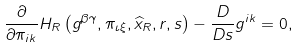Convert formula to latex. <formula><loc_0><loc_0><loc_500><loc_500>\frac { \partial } { \partial \pi _ { i k } } H _ { R } \left ( g ^ { \beta \gamma } , \pi _ { \iota \xi } , \widehat { x } _ { R } , r , s \right ) - \frac { D } { D s } g ^ { i k } = 0 ,</formula> 